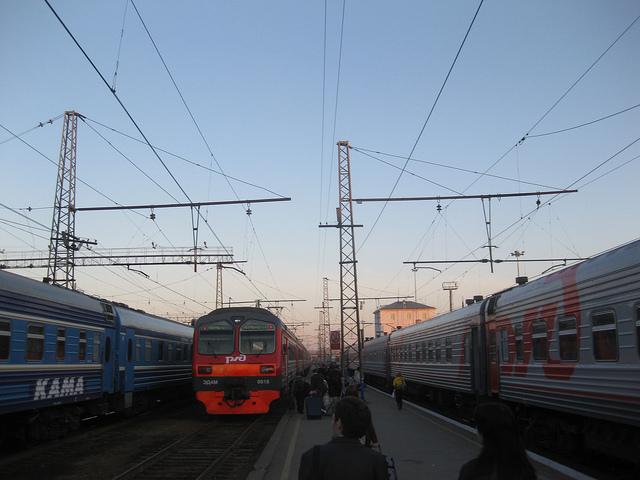Are these trains carrying passengers or cargo?
Answer briefly. Passengers. Are there any buildings?
Write a very short answer. Yes. How many trains are on the tracks?
Be succinct. 3. 